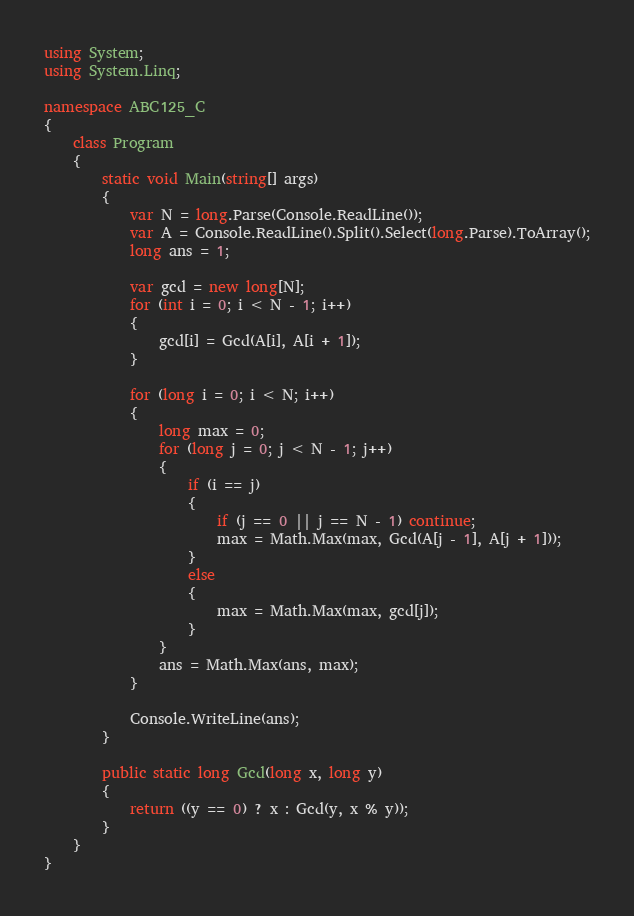<code> <loc_0><loc_0><loc_500><loc_500><_C#_>using System;
using System.Linq;

namespace ABC125_C
{
    class Program
    {
        static void Main(string[] args)
        {
            var N = long.Parse(Console.ReadLine());
            var A = Console.ReadLine().Split().Select(long.Parse).ToArray();
            long ans = 1;

            var gcd = new long[N];
            for (int i = 0; i < N - 1; i++)
            {
                gcd[i] = Gcd(A[i], A[i + 1]);
            }

            for (long i = 0; i < N; i++)
            {
                long max = 0;
                for (long j = 0; j < N - 1; j++)
                {
                    if (i == j)
                    {
                        if (j == 0 || j == N - 1) continue;
                        max = Math.Max(max, Gcd(A[j - 1], A[j + 1]));
                    }
                    else
                    {
                        max = Math.Max(max, gcd[j]);
                    }
                }
                ans = Math.Max(ans, max);
            }

            Console.WriteLine(ans);
        }

        public static long Gcd(long x, long y)
        {
            return ((y == 0) ? x : Gcd(y, x % y));
        }
    }
}
</code> 